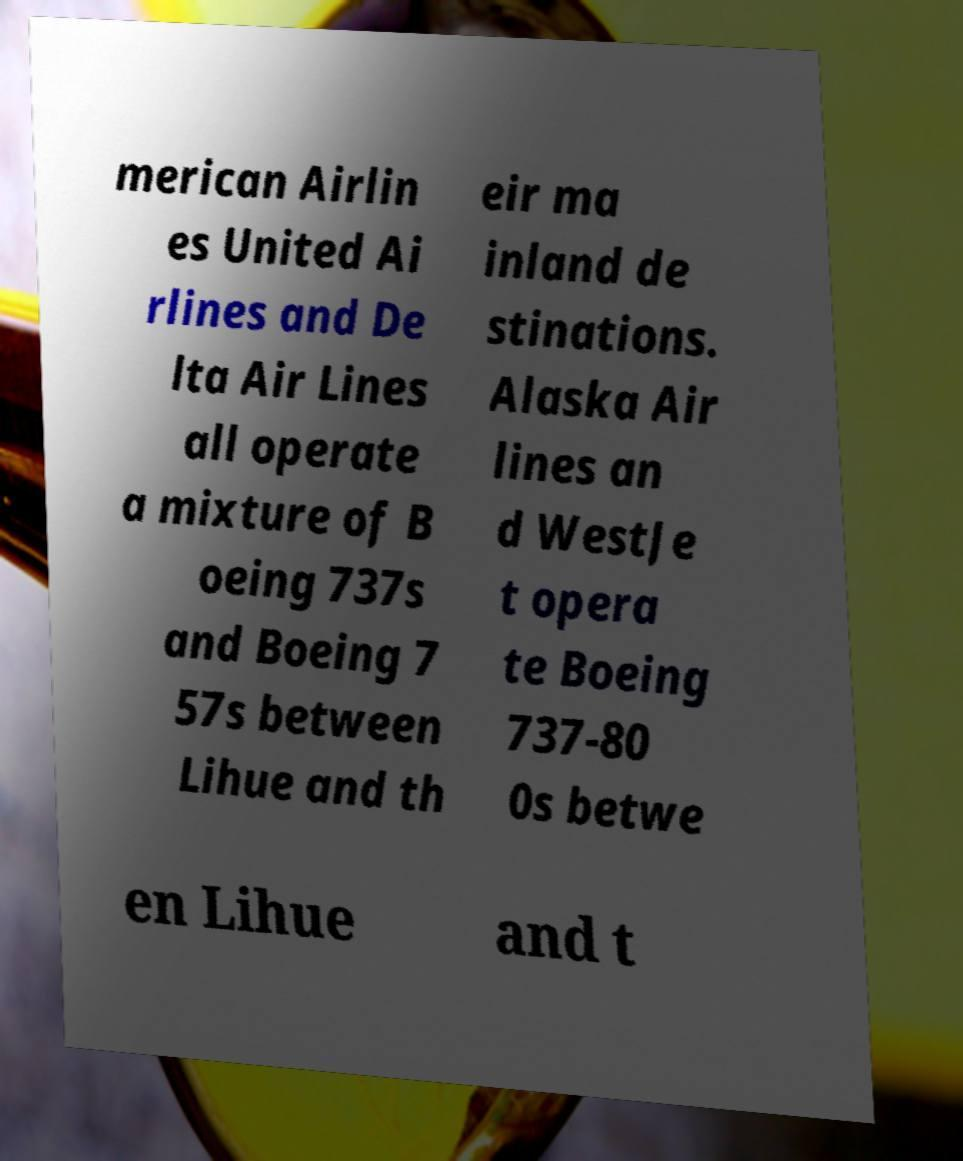For documentation purposes, I need the text within this image transcribed. Could you provide that? merican Airlin es United Ai rlines and De lta Air Lines all operate a mixture of B oeing 737s and Boeing 7 57s between Lihue and th eir ma inland de stinations. Alaska Air lines an d WestJe t opera te Boeing 737-80 0s betwe en Lihue and t 